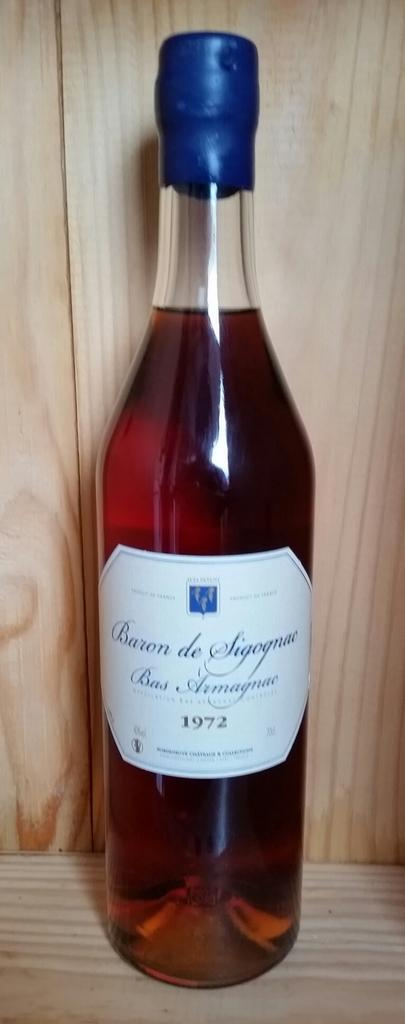<image>
Render a clear and concise summary of the photo. A bottle with the words Baron de Sigognac Bas Armagnac 1972 on the label is on a wooden shelf. 